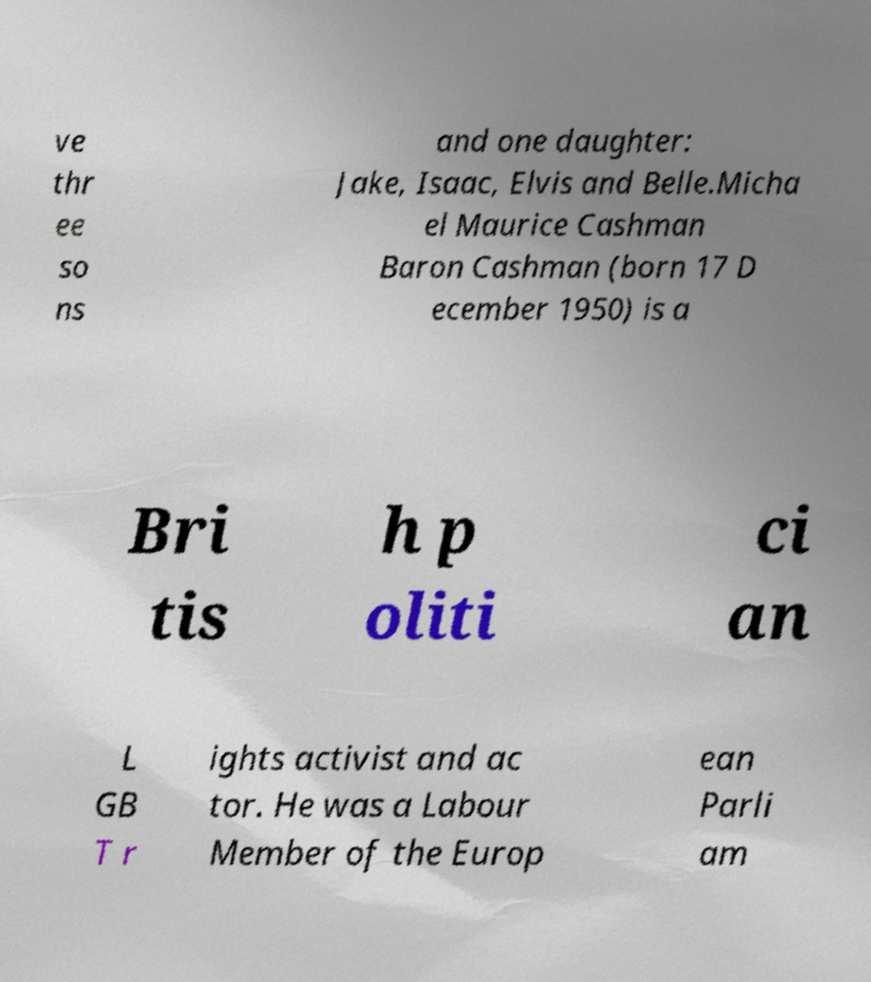Could you extract and type out the text from this image? ve thr ee so ns and one daughter: Jake, Isaac, Elvis and Belle.Micha el Maurice Cashman Baron Cashman (born 17 D ecember 1950) is a Bri tis h p oliti ci an L GB T r ights activist and ac tor. He was a Labour Member of the Europ ean Parli am 